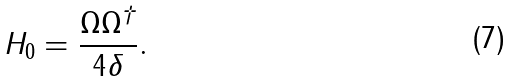<formula> <loc_0><loc_0><loc_500><loc_500>H _ { 0 } = \frac { \Omega \Omega ^ { \dagger } } { 4 \delta } .</formula> 